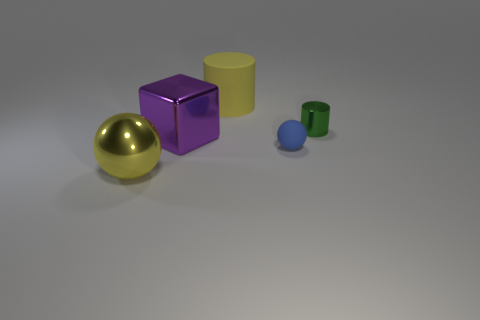Are there any small green metal cylinders on the left side of the rubber thing behind the cylinder in front of the big rubber object?
Provide a short and direct response. No. What shape is the other matte object that is the same size as the purple object?
Keep it short and to the point. Cylinder. How many large objects are either balls or green cylinders?
Your answer should be very brief. 1. What color is the large block that is made of the same material as the small green cylinder?
Your answer should be compact. Purple. Is the shape of the rubber object behind the green metallic cylinder the same as the rubber object that is in front of the purple metal thing?
Offer a very short reply. No. What number of shiny things are either large yellow cylinders or big yellow spheres?
Provide a succinct answer. 1. What material is the other object that is the same color as the big rubber object?
Your answer should be very brief. Metal. Is there anything else that is the same shape as the tiny rubber thing?
Provide a succinct answer. Yes. What is the material of the tiny object behind the tiny matte thing?
Offer a terse response. Metal. Are the thing that is behind the small green cylinder and the small ball made of the same material?
Your response must be concise. Yes. 